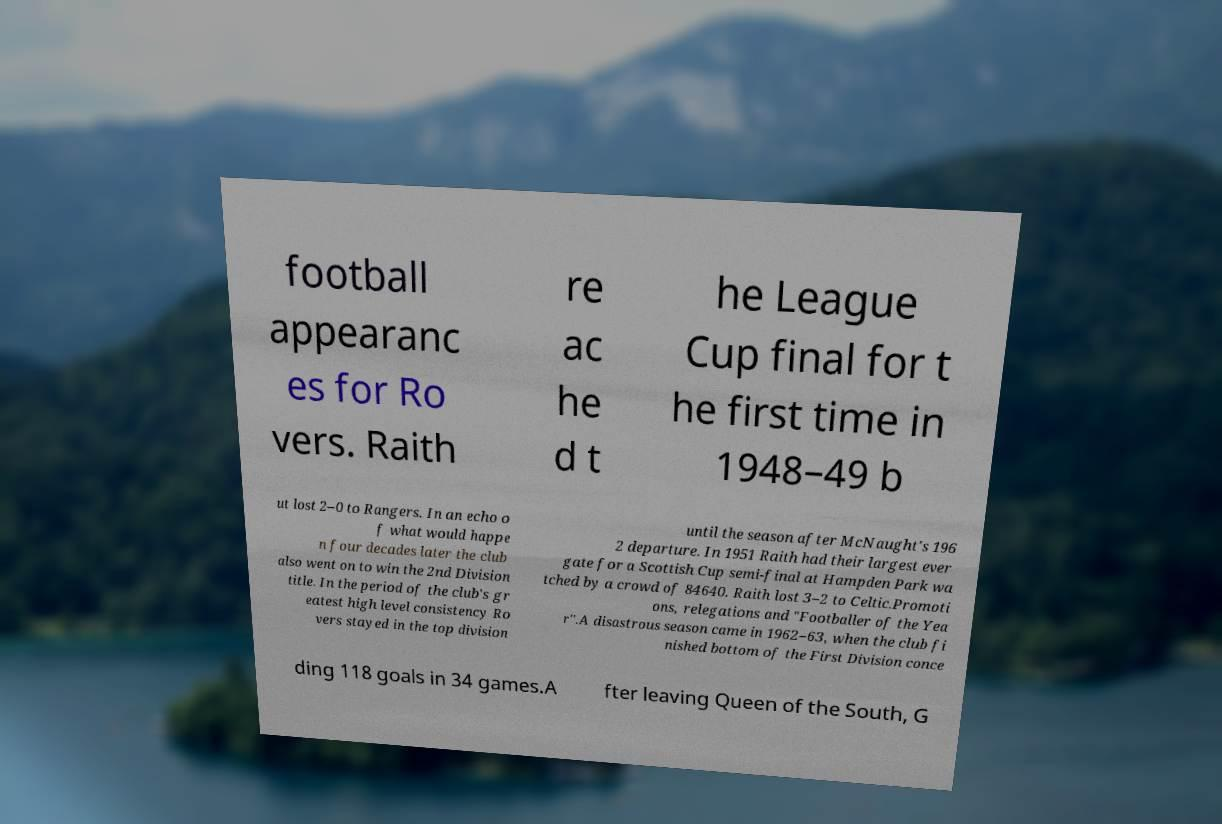Could you assist in decoding the text presented in this image and type it out clearly? football appearanc es for Ro vers. Raith re ac he d t he League Cup final for t he first time in 1948–49 b ut lost 2–0 to Rangers. In an echo o f what would happe n four decades later the club also went on to win the 2nd Division title. In the period of the club's gr eatest high level consistency Ro vers stayed in the top division until the season after McNaught's 196 2 departure. In 1951 Raith had their largest ever gate for a Scottish Cup semi-final at Hampden Park wa tched by a crowd of 84640. Raith lost 3–2 to Celtic.Promoti ons, relegations and "Footballer of the Yea r".A disastrous season came in 1962–63, when the club fi nished bottom of the First Division conce ding 118 goals in 34 games.A fter leaving Queen of the South, G 